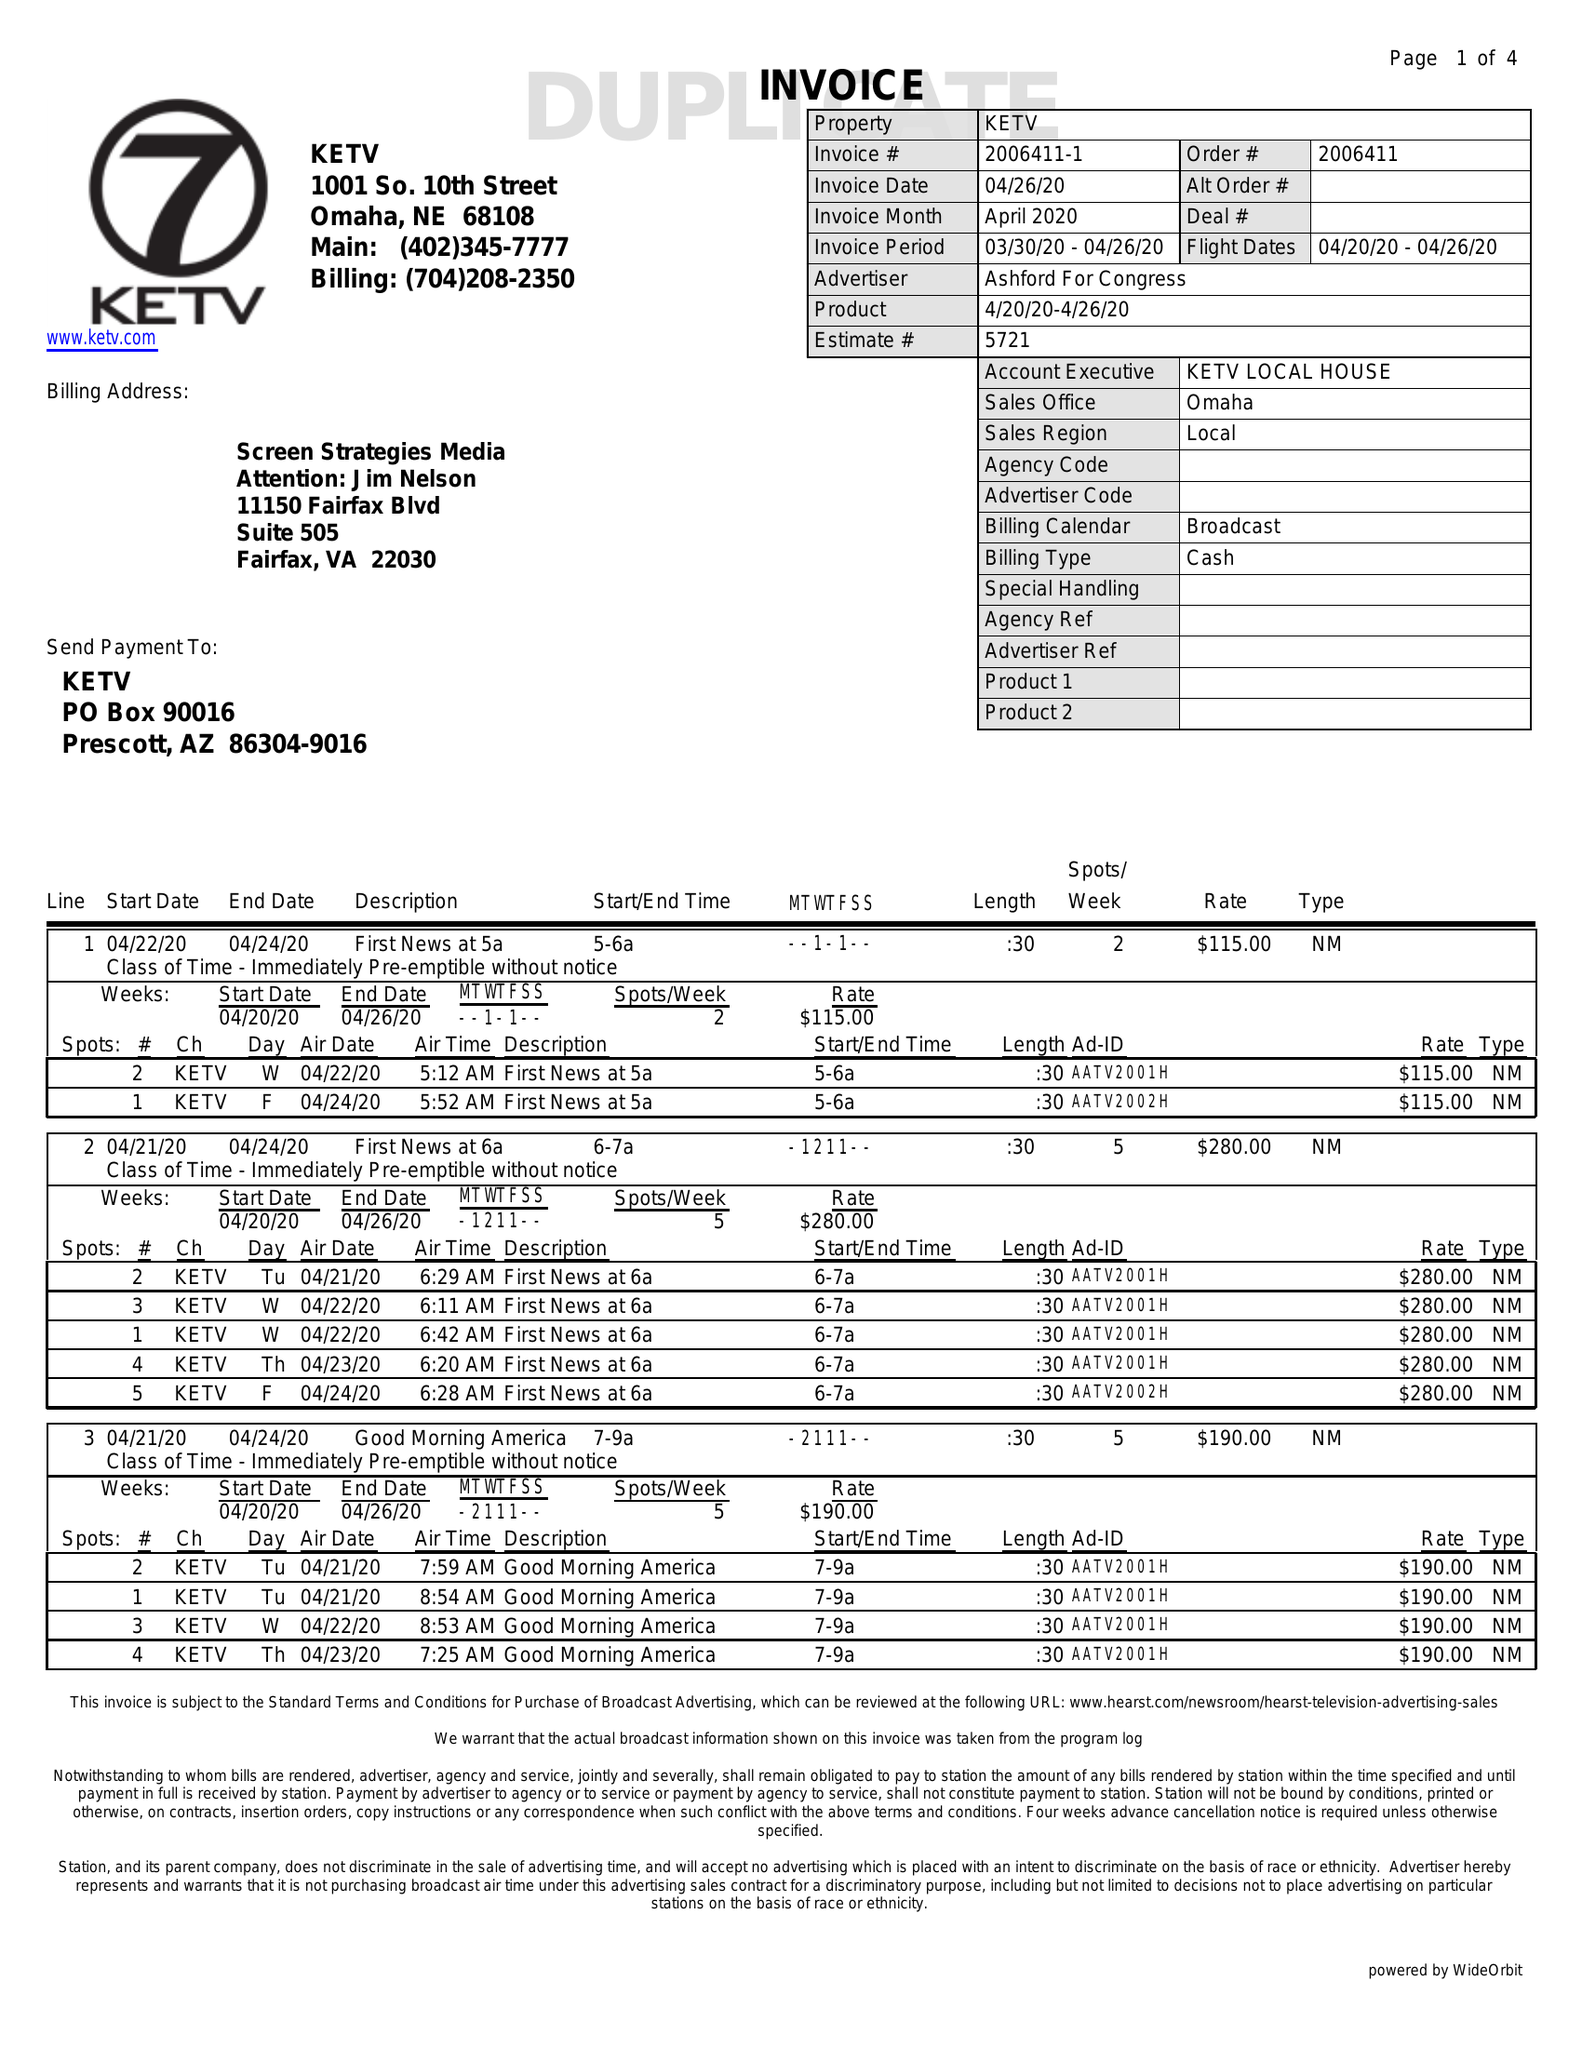What is the value for the gross_amount?
Answer the question using a single word or phrase. 7465.00 